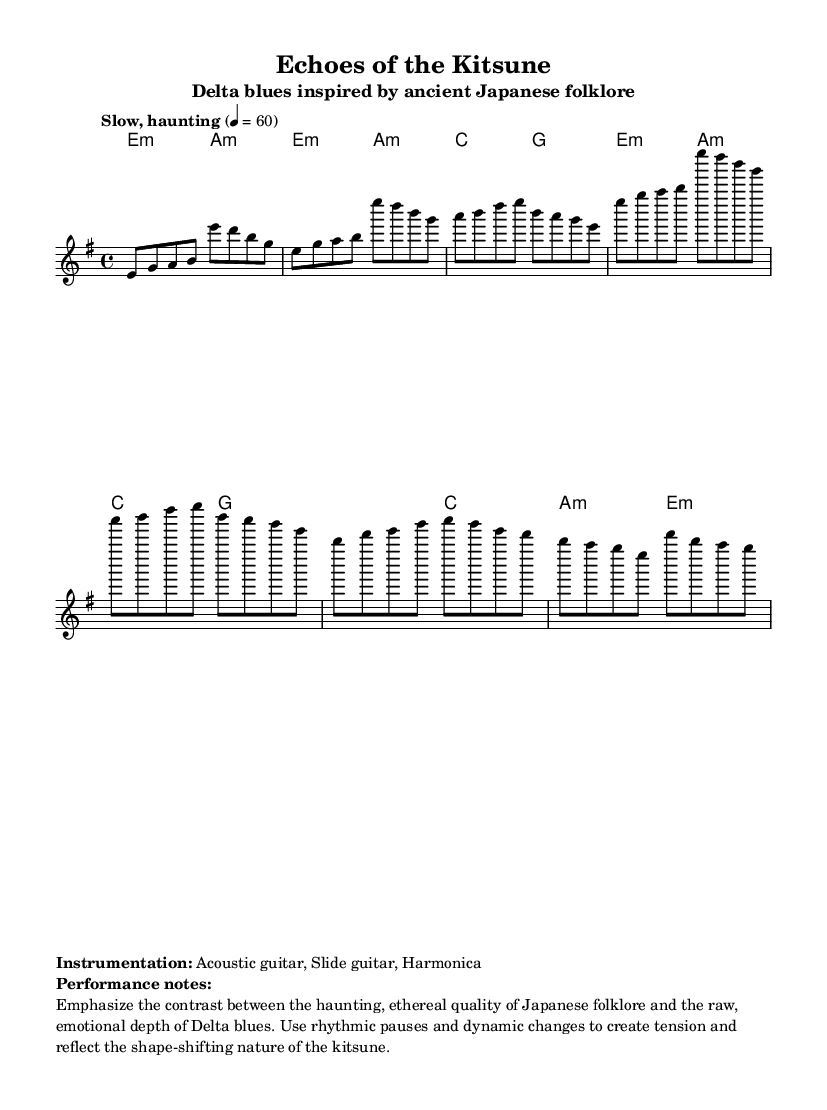What is the key signature of this music? The key signature is indicated by the sharps or flats at the beginning of the staff. In this case, it is E minor, which has one sharp.
Answer: E minor What is the time signature of this piece? The time signature is found at the beginning of the score, notated as 4/4. This means there are four beats per measure, and each quarter note receives one beat.
Answer: 4/4 What is the tempo marking of this composition? The tempo marking, which indicates the speed and feel of the piece, is "Slow, haunting." It suggests that the music should be played at a relaxed pace, contributing to its emotional quality.
Answer: Slow, haunting How many sections are there in the piece? By analyzing the structure outlined in the sheet music, there are three distinct sections: Verse 1, Chorus, and Bridge. Each section presents a different musical theme or contrast.
Answer: Three In what style is this piece primarily composed? The style is indicated by the title and the instrumentation, which suggests a blend of Delta blues and elements inspired by Japanese folklore, such as the reference to the kitsune.
Answer: Delta blues What kind of instrumentation is used in this piece? The instrumentation is noted in the markup section of the score, which lists specific instruments that create the accompanying sound. The instruments mentioned are Acoustic guitar, Slide guitar, and Harmonica.
Answer: Acoustic guitar, Slide guitar, Harmonica What does the performance note suggest regarding dynamic emphasis? The performance notes indicate that musicians should emphasize the contrast between different qualities, specifically focusing on rhythmic pauses and dynamic changes to enhance the emotional depth of the music.
Answer: Contrast between haunting and emotional depth 